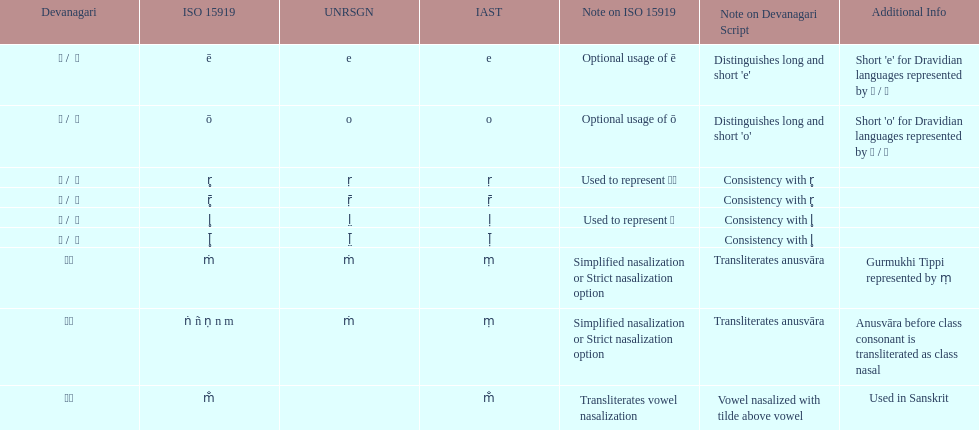What unrsgn is listed previous to the o? E. 